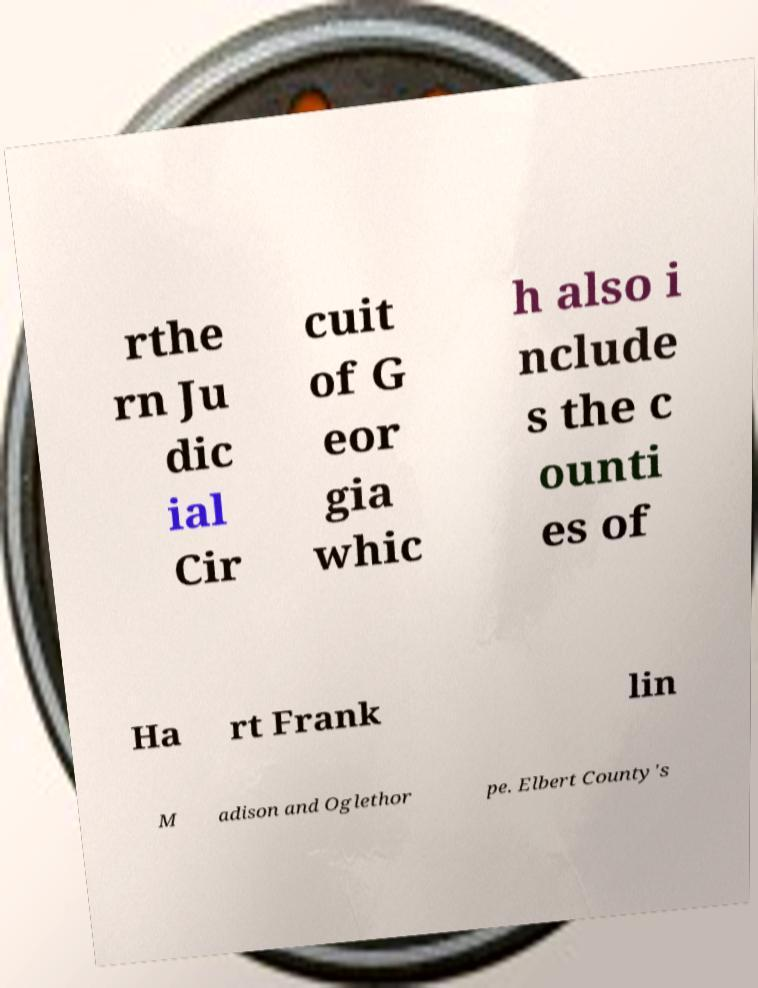Could you extract and type out the text from this image? rthe rn Ju dic ial Cir cuit of G eor gia whic h also i nclude s the c ounti es of Ha rt Frank lin M adison and Oglethor pe. Elbert County's 